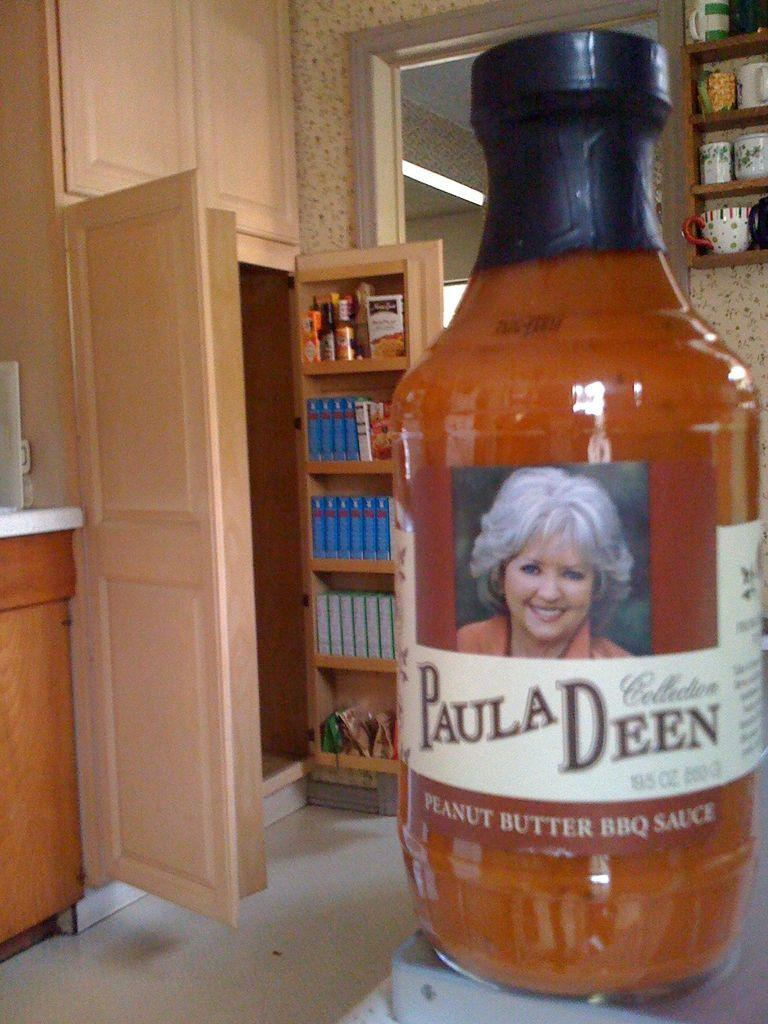<image>
Summarize the visual content of the image. With an open pantry in the background, a bottle of Paula Deen Peanut butter BBQ sauce is on a counter top. 